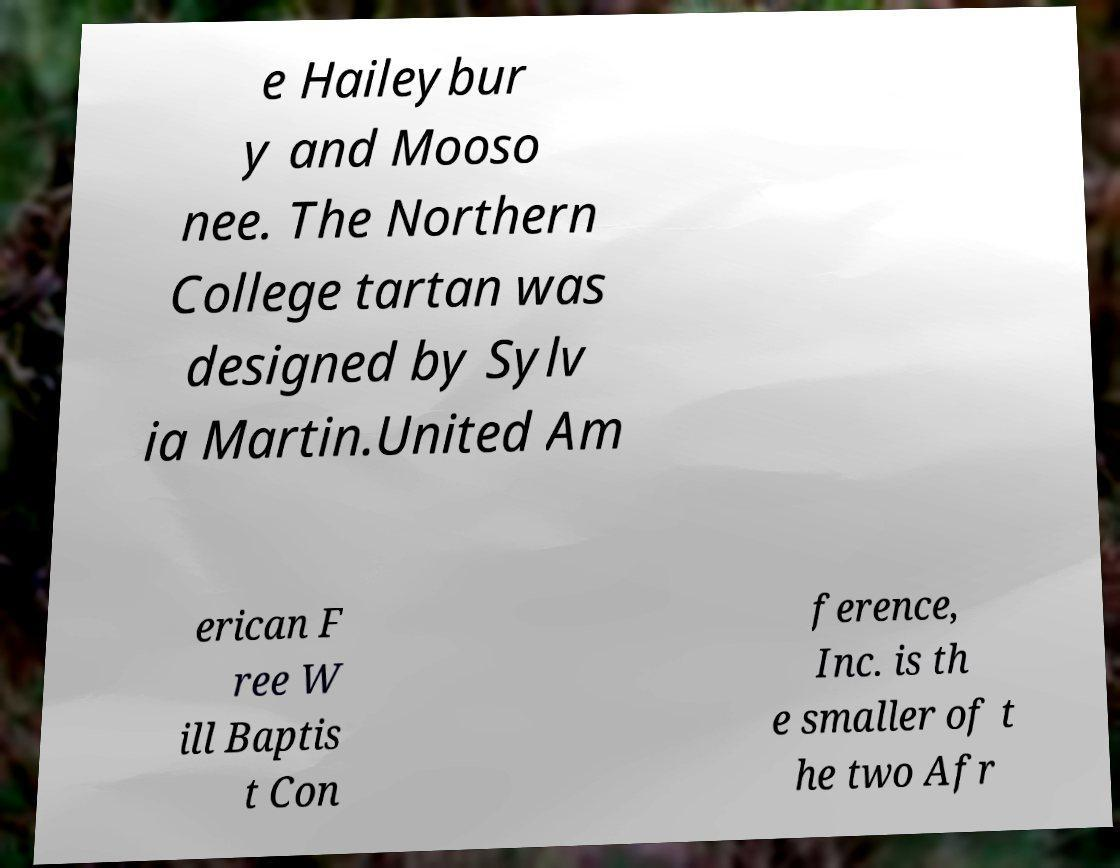For documentation purposes, I need the text within this image transcribed. Could you provide that? e Haileybur y and Mooso nee. The Northern College tartan was designed by Sylv ia Martin.United Am erican F ree W ill Baptis t Con ference, Inc. is th e smaller of t he two Afr 